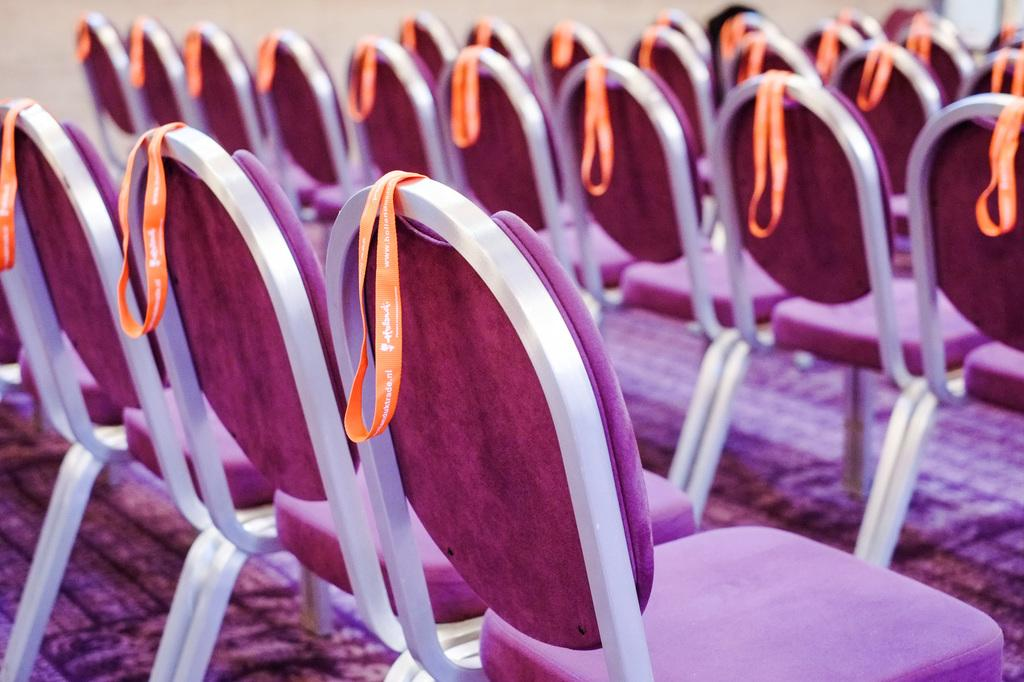What is attached to the chairs in the image? There are tags on the chairs. What can be seen in the background of the image? There is a wall in the background. What type of pen is being used to write on the wall in the image? There is no pen or writing on the wall in the image; only the chairs with tags and the wall are present. 